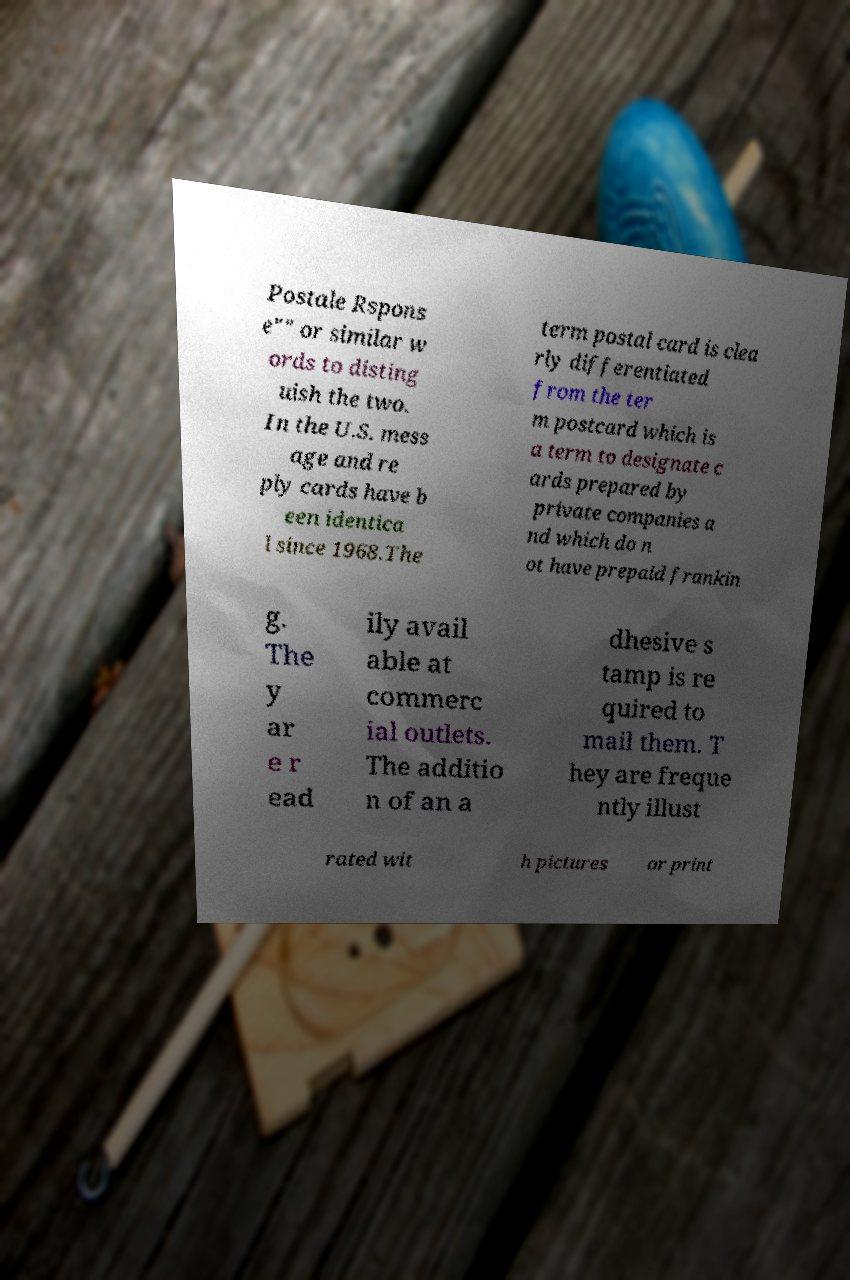What messages or text are displayed in this image? I need them in a readable, typed format. Postale Rspons e"" or similar w ords to disting uish the two. In the U.S. mess age and re ply cards have b een identica l since 1968.The term postal card is clea rly differentiated from the ter m postcard which is a term to designate c ards prepared by private companies a nd which do n ot have prepaid frankin g. The y ar e r ead ily avail able at commerc ial outlets. The additio n of an a dhesive s tamp is re quired to mail them. T hey are freque ntly illust rated wit h pictures or print 